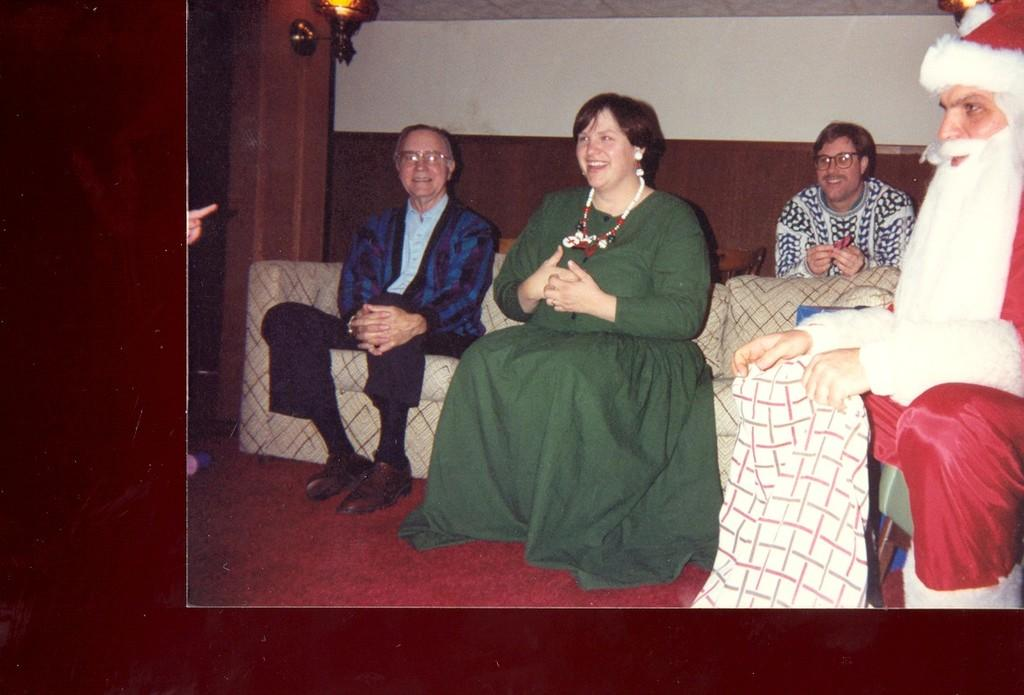What is the main subject of the image? The main subject of the image is a photo. What can be seen in the photo? The photo contains people sitting on a sofa. Is there anyone else visible in the image besides the people in the photo? Yes, there is a person on the right side of the image wearing a Christmas father dress. What type of dinner is being served in the image? There is no dinner present in the image; it features a photo of people sitting on a sofa and a person wearing a Christmas father dress. What kind of shade is being used to protect the people in the image? There is no shade present in the image; it is an indoor setting with a photo and a person wearing a Christmas father dress. 